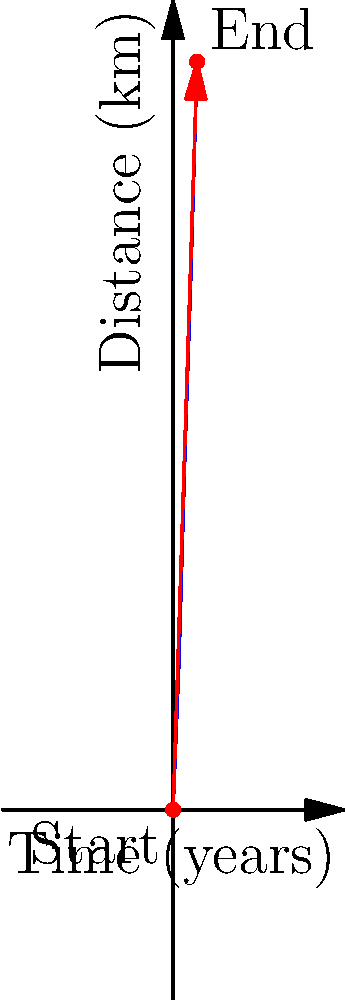As a filmmaker documenting your family's cultural migration, you've plotted the journey over 80 years on a graph where the x-axis represents time in years and the y-axis represents distance traveled in kilometers. The start point is (0,0) and the end point is (80,2500). What is the magnitude and direction (in degrees from the positive x-axis) of the vector representing this migration pattern? To solve this problem, we need to follow these steps:

1. Calculate the components of the vector:
   x-component: $\Delta x = 80 - 0 = 80$ years
   y-component: $\Delta y = 2500 - 0 = 2500$ km

2. Calculate the magnitude of the vector using the Pythagorean theorem:
   $magnitude = \sqrt{(\Delta x)^2 + (\Delta y)^2}$
   $magnitude = \sqrt{80^2 + 2500^2} = \sqrt{6400 + 6250000} = \sqrt{6256400} \approx 2501.28$

3. Calculate the direction using the arctangent function:
   $\theta = \arctan(\frac{\Delta y}{\Delta x})$
   $\theta = \arctan(\frac{2500}{80}) \approx 88.17°$

Therefore, the vector has a magnitude of approximately 2501.28 units (which represents a combination of years and kilometers) and a direction of about 88.17° from the positive x-axis.
Answer: Magnitude: 2501.28, Direction: 88.17° 